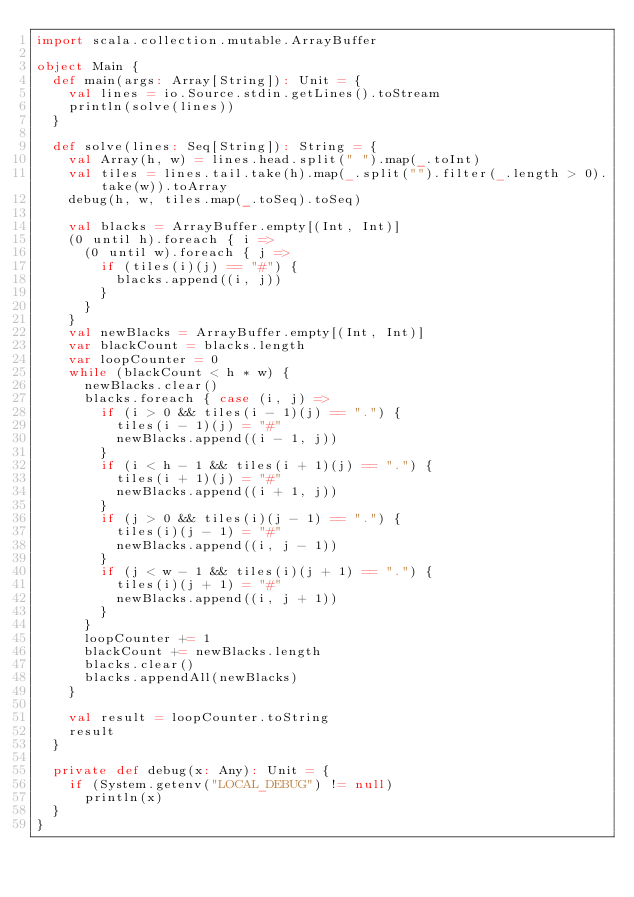Convert code to text. <code><loc_0><loc_0><loc_500><loc_500><_Scala_>import scala.collection.mutable.ArrayBuffer

object Main {
  def main(args: Array[String]): Unit = {
    val lines = io.Source.stdin.getLines().toStream
    println(solve(lines))
  }

  def solve(lines: Seq[String]): String = {
    val Array(h, w) = lines.head.split(" ").map(_.toInt)
    val tiles = lines.tail.take(h).map(_.split("").filter(_.length > 0).take(w)).toArray
    debug(h, w, tiles.map(_.toSeq).toSeq)

    val blacks = ArrayBuffer.empty[(Int, Int)]
    (0 until h).foreach { i =>
      (0 until w).foreach { j =>
        if (tiles(i)(j) == "#") {
          blacks.append((i, j))
        }
      }
    }
    val newBlacks = ArrayBuffer.empty[(Int, Int)]
    var blackCount = blacks.length
    var loopCounter = 0
    while (blackCount < h * w) {
      newBlacks.clear()
      blacks.foreach { case (i, j) =>
        if (i > 0 && tiles(i - 1)(j) == ".") {
          tiles(i - 1)(j) = "#"
          newBlacks.append((i - 1, j))
        }
        if (i < h - 1 && tiles(i + 1)(j) == ".") {
          tiles(i + 1)(j) = "#"
          newBlacks.append((i + 1, j))
        }
        if (j > 0 && tiles(i)(j - 1) == ".") {
          tiles(i)(j - 1) = "#"
          newBlacks.append((i, j - 1))
        }
        if (j < w - 1 && tiles(i)(j + 1) == ".") {
          tiles(i)(j + 1) = "#"
          newBlacks.append((i, j + 1))
        }
      }
      loopCounter += 1
      blackCount += newBlacks.length
      blacks.clear()
      blacks.appendAll(newBlacks)
    }

    val result = loopCounter.toString
    result
  }

  private def debug(x: Any): Unit = {
    if (System.getenv("LOCAL_DEBUG") != null)
      println(x)
  }
}
</code> 